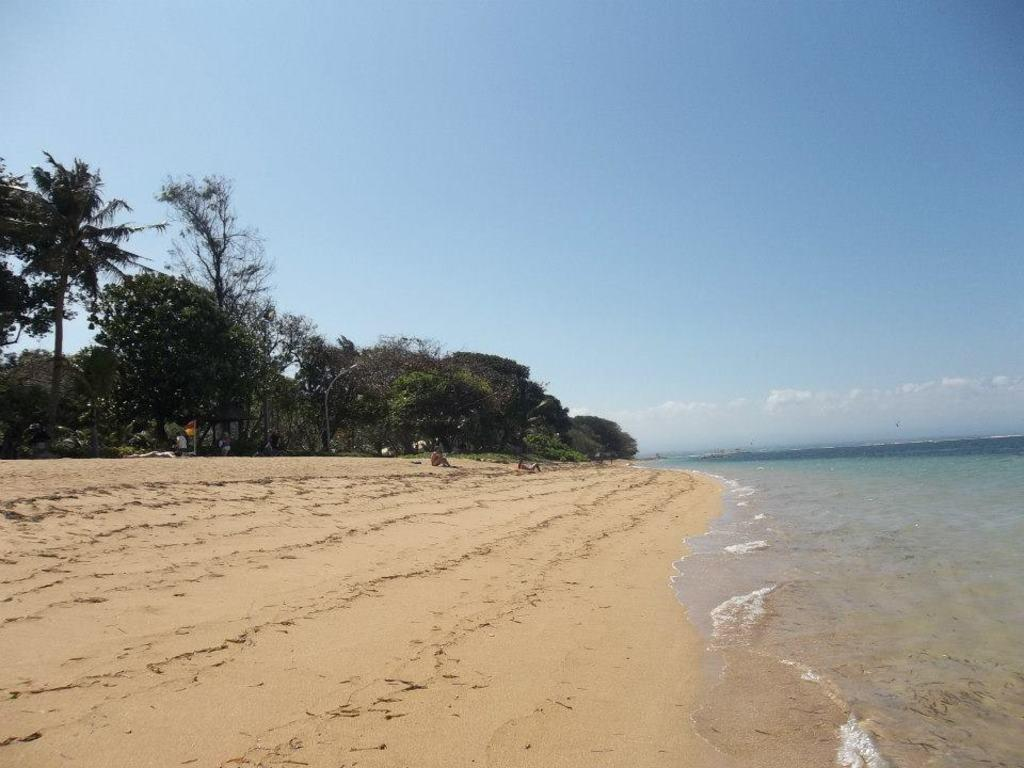Who or what can be seen in the image? There are people in the image. What type of surface are the people on? The people are on sand. What is the location of the flag in the image? The flag is in the image. What type of vegetation is present in the image? There are trees in the image. What natural feature can be seen in the image? There is water visible in the image. What is visible in the background of the image? The sky is visible in the background of the image, and clouds are present in the sky. What type of collar can be seen on the deer in the image? There is no deer present in the image, and therefore no collar can be seen. What room are the people in the image located in? The image does not depict an indoor setting, so there is no room mentioned. 